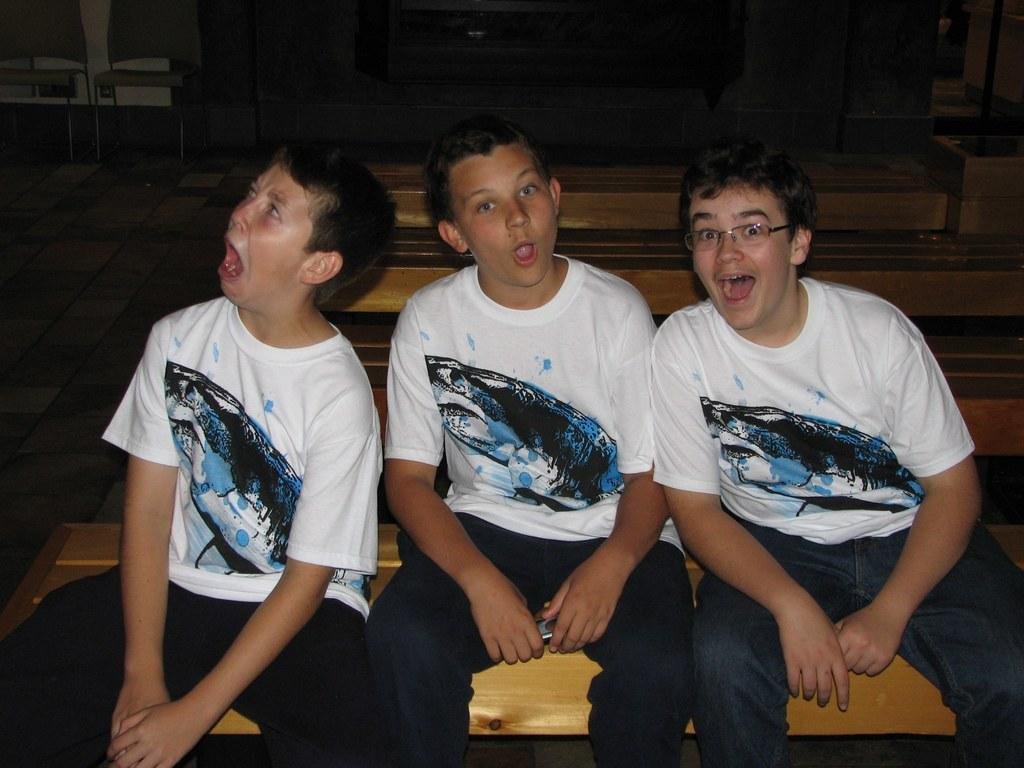How many boys are in the image? There are three boys in the image. What are the boys doing in the image? The boys are sitting on a bench. What are the boys wearing in the image? All the boys are wearing white T-shirts. Can you describe any specific features of one of the boys? One of the boys is wearing spectacles. What is the color of the background in the image? The background of the image is dark. What type of operation is being performed on the cats in the image? There are no cats present in the image, and therefore no operation is being performed. What is the cause of the war depicted in the image? There is no war depicted in the image; it features three boys sitting on a bench. 